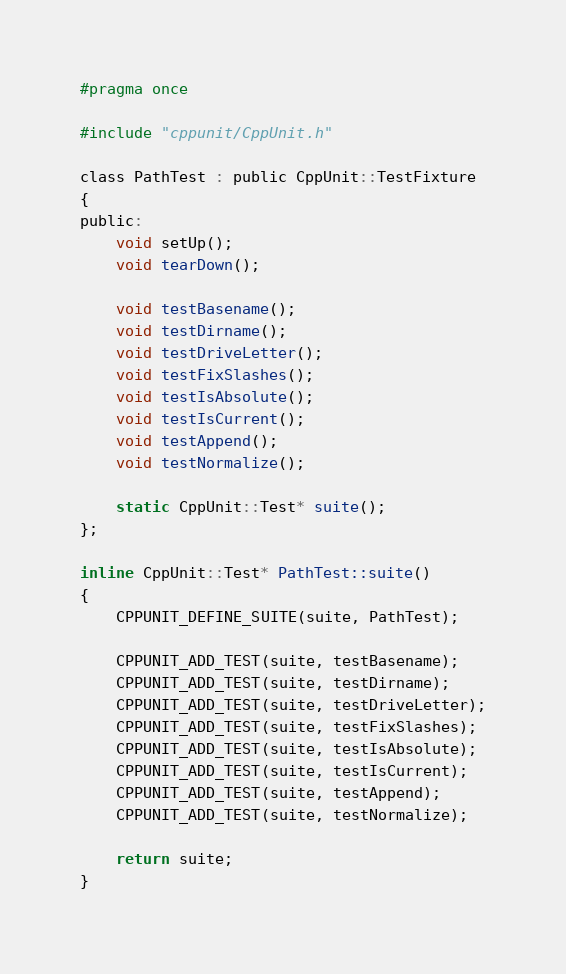Convert code to text. <code><loc_0><loc_0><loc_500><loc_500><_C_>#pragma once

#include "cppunit/CppUnit.h"

class PathTest : public CppUnit::TestFixture
{
public:
	void setUp();
	void tearDown();

	void testBasename();
	void testDirname();
	void testDriveLetter();
	void testFixSlashes();
	void testIsAbsolute();
	void testIsCurrent();
	void testAppend();
	void testNormalize();

	static CppUnit::Test* suite();
};

inline CppUnit::Test* PathTest::suite()
{
	CPPUNIT_DEFINE_SUITE(suite, PathTest);

	CPPUNIT_ADD_TEST(suite, testBasename);
	CPPUNIT_ADD_TEST(suite, testDirname);
	CPPUNIT_ADD_TEST(suite, testDriveLetter);
	CPPUNIT_ADD_TEST(suite, testFixSlashes);
	CPPUNIT_ADD_TEST(suite, testIsAbsolute);
	CPPUNIT_ADD_TEST(suite, testIsCurrent);
	CPPUNIT_ADD_TEST(suite, testAppend);
	CPPUNIT_ADD_TEST(suite, testNormalize);

	return suite;
}

</code> 